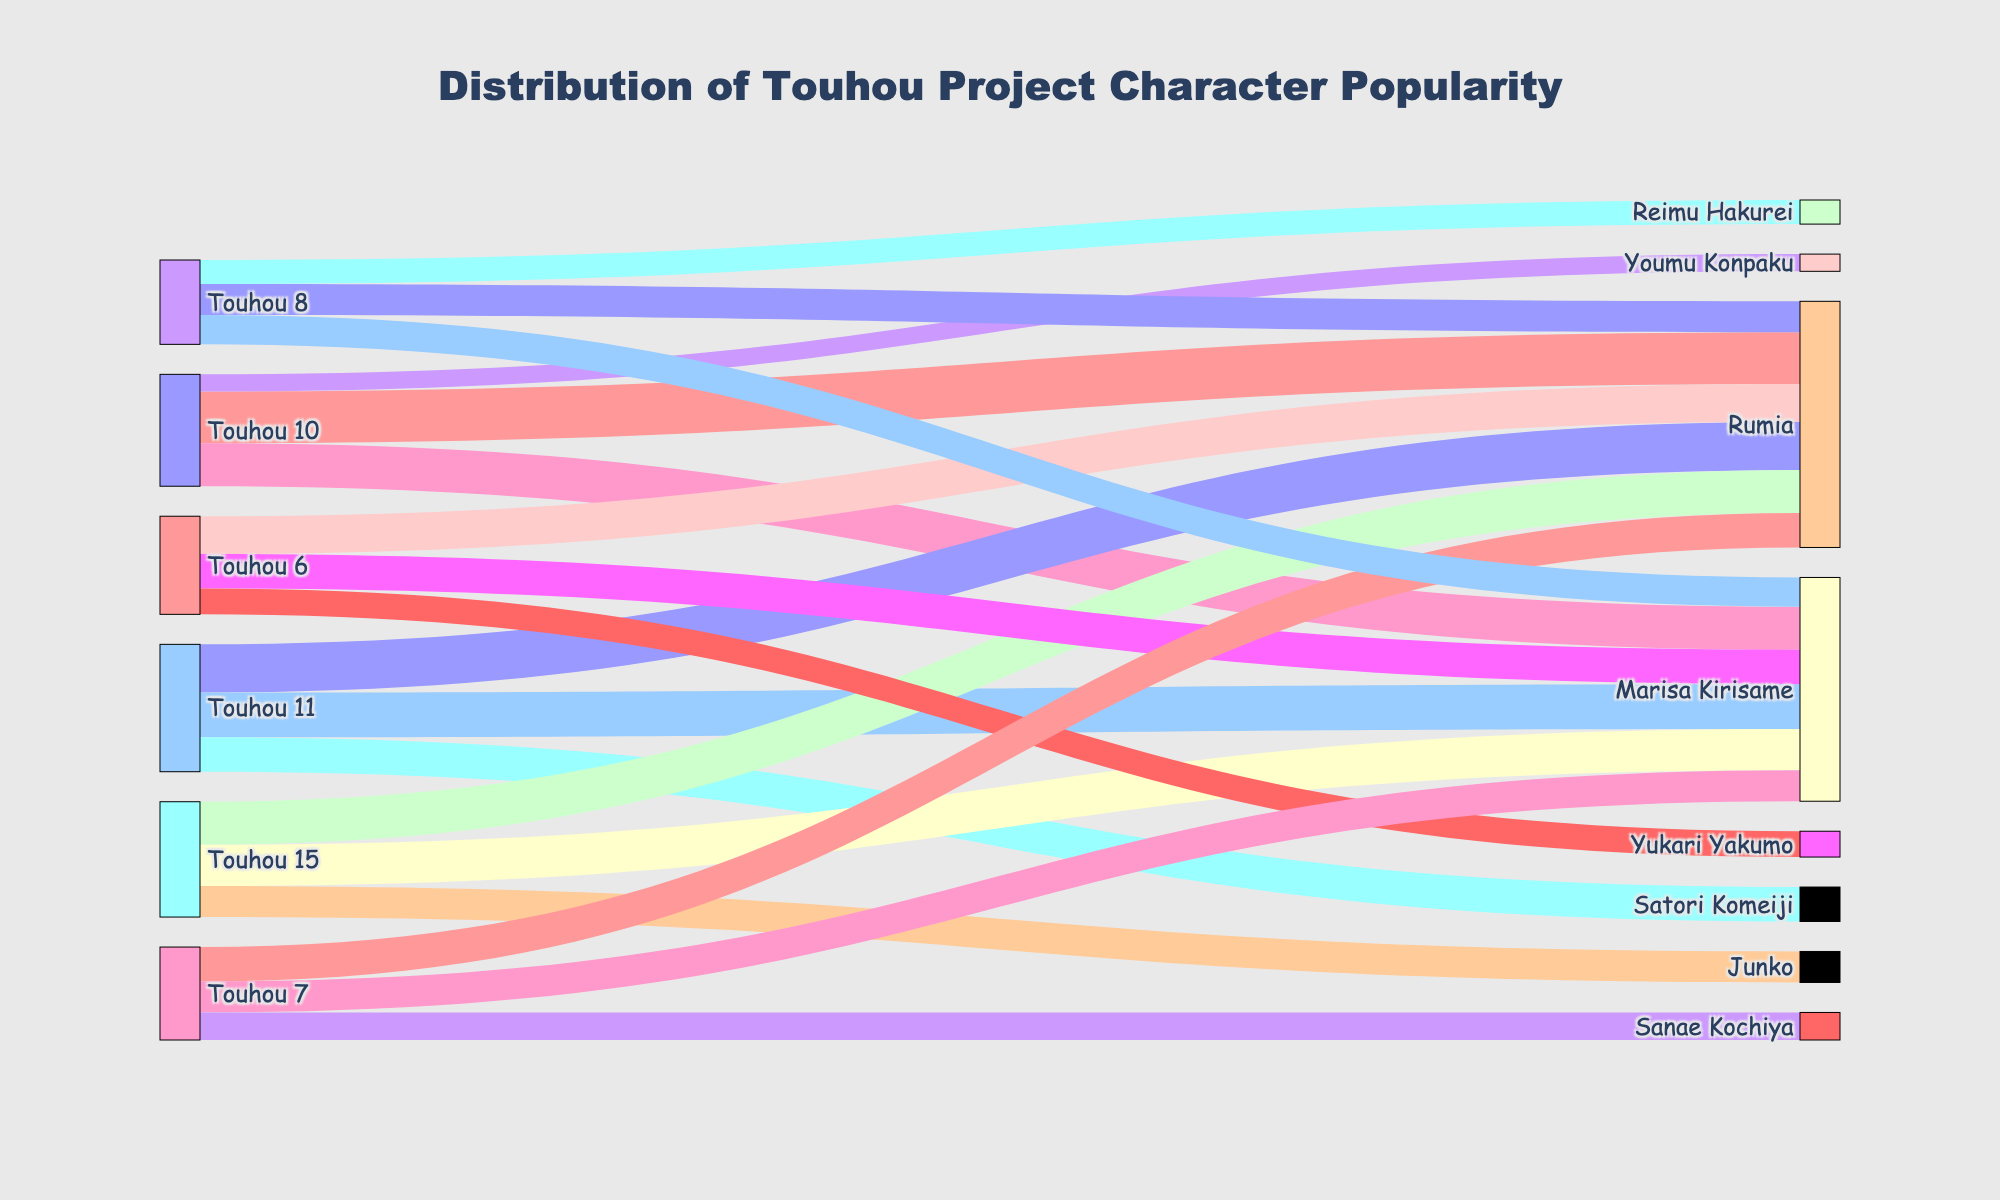What is the title of the Sankey diagram? The title is found at the top of the Sankey diagram. It reads "Distribution of Touhou Project Character Popularity".
Answer: Distribution of Touhou Project Character Popularity How many characters from Touhou 7 appear in the diagram? To answer this, count the different "target" nodes connected to the "source" node "Touhou 7". They are Reimu Hakurei, Marisa Kirisame, and Youmu Konpaku.
Answer: Three What is the total popularity value for Reimu Hakurei across all games? To find this, sum the values connected to "Reimu Hakurei" from different games. The values are 30 (Touhou 6), 28 (Touhou 7), 25 (Touhou 8), 22 (Touhou 10), 20 (Touhou 11), and 18 (Touhou 15). Therefore, 30 + 28 + 25 + 22 + 20 + 18 = 143.
Answer: 143 Which game has the lowest total character popularity? To determine this, sum the character popularity values for each game and compare. Touhou 6 has 65 (30 + 25 + 10), Touhou 7 has 74 (28 + 26 + 20), Touhou 8 has 67 (25 + 24 + 18), Touhou 10 has 57 (22 + 20 + 15), Touhou 11 has 54 (20 + 18 + 16), and Touhou 15 has 49 (18 + 17 + 14). The game with the lowest value is Touhou 15.
Answer: Touhou 15 Which two characters have the closest popularity values in Touhou 11? Look at the "target" nodes for "Touhou 11" and compare their values. Reimu Hakurei has 20, Marisa Kirisame has 18, and Satori Komeiji has 16. Marisa Kirisame and Satori Komeiji have the closest values (18 and 16).
Answer: Marisa Kirisame and Satori Komeiji How many games feature Yukari Yakumo? Search for Yukari Yakumo in the "target" nodes and count the games connected to it. Yukari Yakumo appears only once, in Touhou 8.
Answer: One What is the difference in popularity between Reimu Hakurei and Marisa Kirisame in Touhou 10? To find the difference, subtract the popularity value of Marisa Kirisame from that of Reimu Hakurei in Touhou 10. Reimu Hakurei has a value of 22 and Marisa Kirisame has 20, so the difference is 22 - 20.
Answer: Two How many characters have popularity values greater than or equal to 20 in Touhou 7? Identify the characters from Touhou 7 with values of 20 or more. These characters are Reimu Hakurei (28), Marisa Kirisame (26), and Youmu Konpaku (20). Therefore, there are three characters.
Answer: Three In Touhou 8, which character has the highest popularity value? Compare the popularity values of the characters from Touhou 8. Reimu Hakurei has 25, Marisa Kirisame has 24, and Yukari Yakumo has 18. Thus, Reimu Hakurei has the highest value.
Answer: Reimu Hakurei 